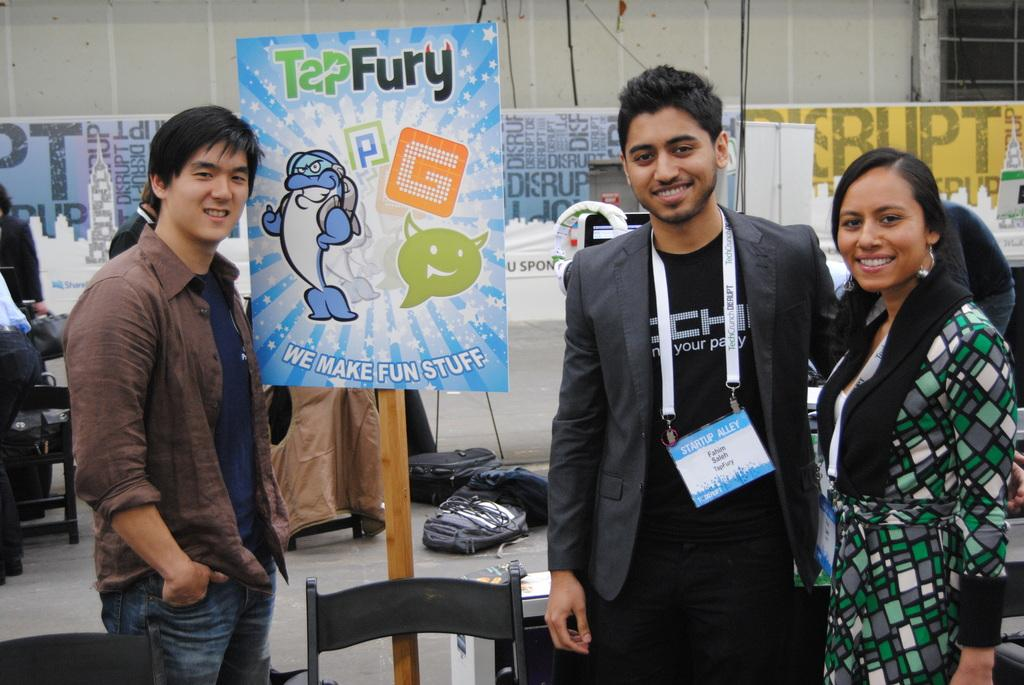What can be seen in the image? There are people standing in the image. What is visible in the background of the image? There is a board, bags, chairs, and banners in the background of the image. What type of milk is being served at the event depicted in the image? There is no mention of milk or any event in the image, so it cannot be determined from the image. 